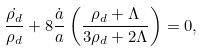<formula> <loc_0><loc_0><loc_500><loc_500>\frac { \dot { \rho _ { d } } } { \rho _ { d } } + 8 \frac { \dot { a } } { a } \left ( \frac { \rho _ { d } + \Lambda } { 3 \rho _ { d } + 2 \Lambda } \right ) = 0 ,</formula> 